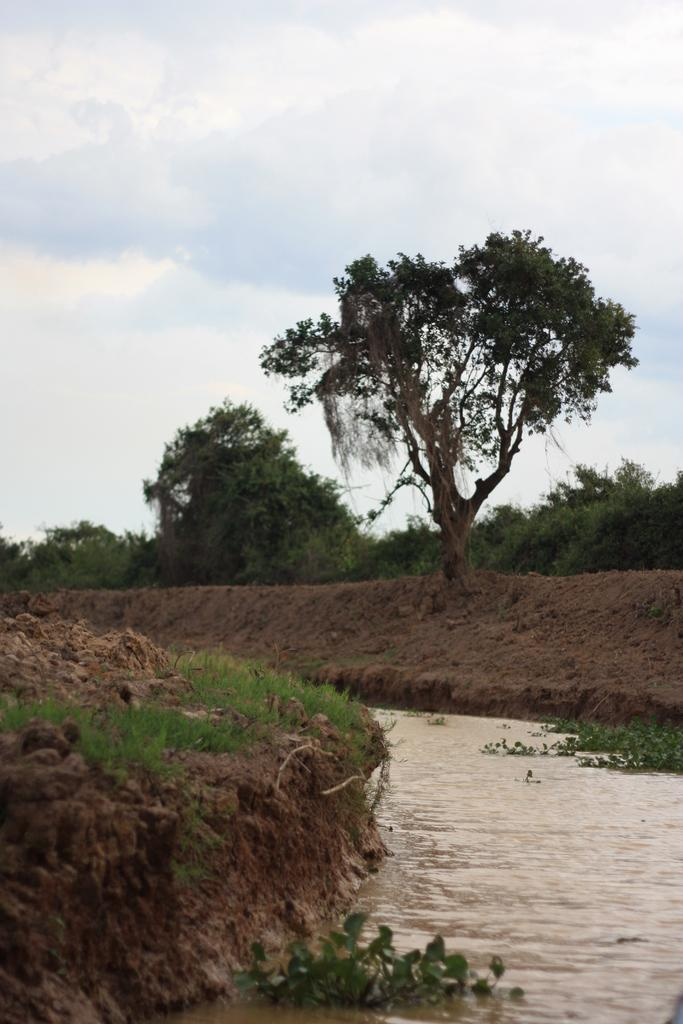What type of vegetation can be seen in the image? There are trees in the image. What type of terrain is visible in the image? There is mud and water visible in the image. What is the color of the sky in the image? The sky is blue and white in color. Can you see any chickens exchanging items in the image? There are no chickens or exchanges present in the image. How many times do the trees touch the sky in the image? The trees do not touch the sky in the image; they are separate entities. 